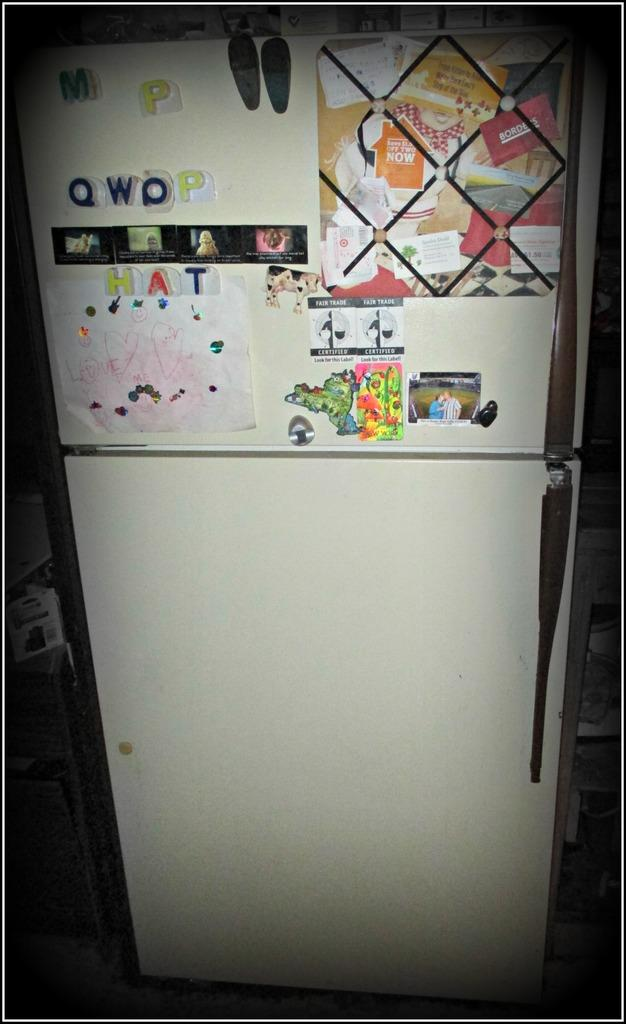Provide a one-sentence caption for the provided image. A fridge with large letters that read QWOP and HAT. 